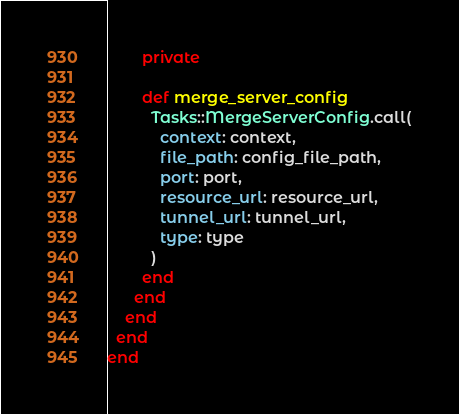<code> <loc_0><loc_0><loc_500><loc_500><_Ruby_>
        private

        def merge_server_config
          Tasks::MergeServerConfig.call(
            context: context,
            file_path: config_file_path,
            port: port,
            resource_url: resource_url,
            tunnel_url: tunnel_url,
            type: type
          )
        end
      end
    end
  end
end
</code> 